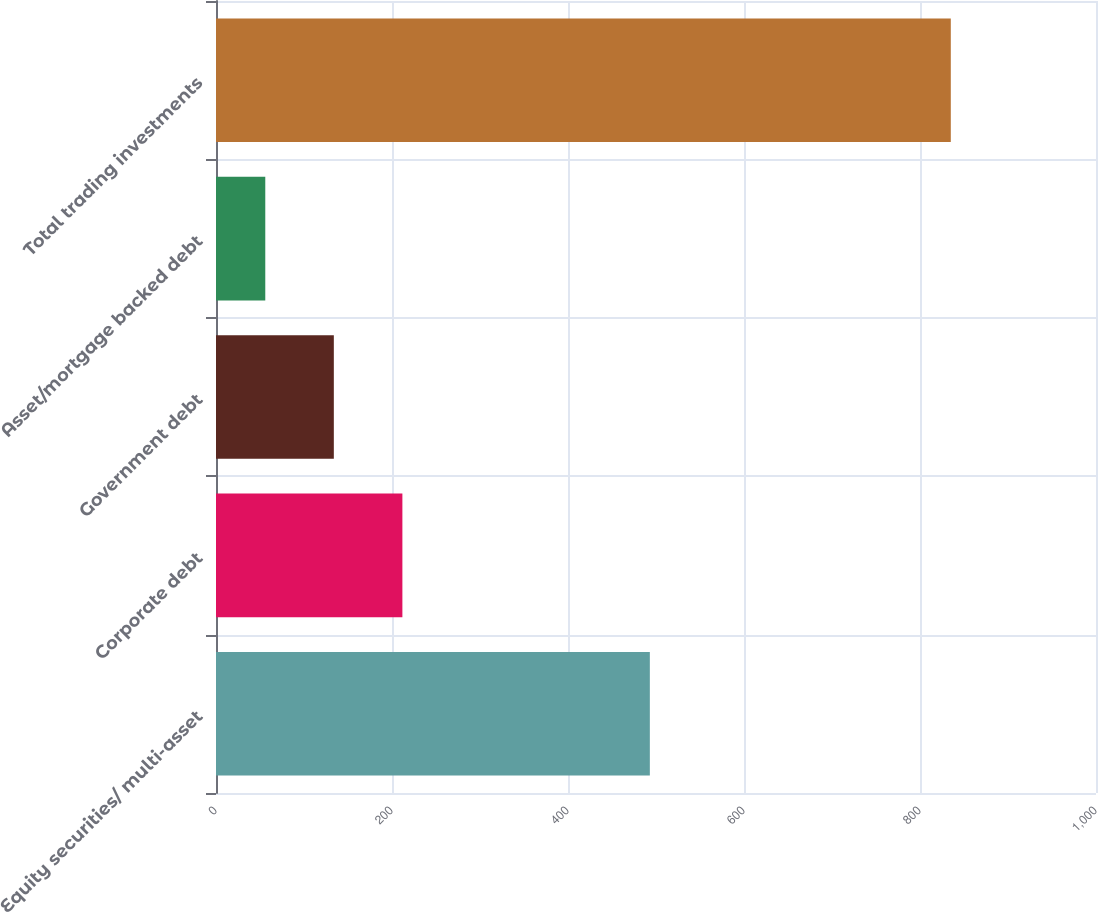Convert chart to OTSL. <chart><loc_0><loc_0><loc_500><loc_500><bar_chart><fcel>Equity securities/ multi-asset<fcel>Corporate debt<fcel>Government debt<fcel>Asset/mortgage backed debt<fcel>Total trading investments<nl><fcel>493<fcel>211.8<fcel>133.9<fcel>56<fcel>835<nl></chart> 